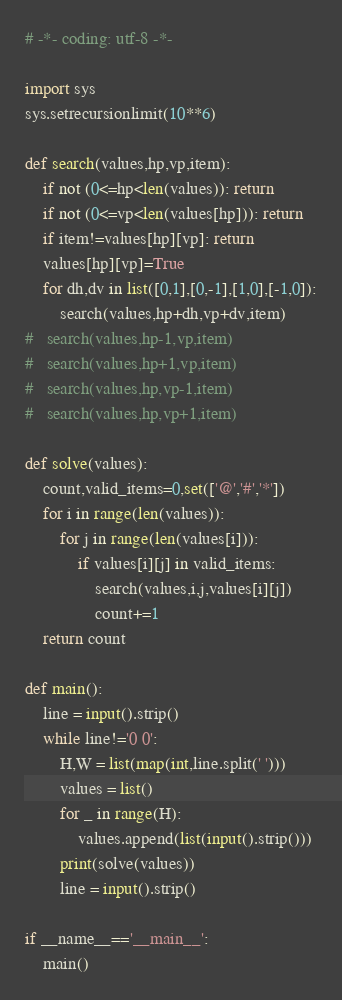Convert code to text. <code><loc_0><loc_0><loc_500><loc_500><_Python_># -*- coding: utf-8 -*-

import sys
sys.setrecursionlimit(10**6)

def search(values,hp,vp,item):
	if not (0<=hp<len(values)): return
	if not (0<=vp<len(values[hp])): return
	if item!=values[hp][vp]: return
	values[hp][vp]=True
	for dh,dv in list([0,1],[0,-1],[1,0],[-1,0]):
		search(values,hp+dh,vp+dv,item)
#	search(values,hp-1,vp,item)
#	search(values,hp+1,vp,item)
#	search(values,hp,vp-1,item)
#	search(values,hp,vp+1,item)

def solve(values):
	count,valid_items=0,set(['@','#','*'])
	for i in range(len(values)):
		for j in range(len(values[i])):
			if values[i][j] in valid_items:
				search(values,i,j,values[i][j])
				count+=1
	return count

def main():
	line = input().strip()
	while line!='0 0':
		H,W = list(map(int,line.split(' ')))
		values = list()
		for _ in range(H):
			values.append(list(input().strip()))
		print(solve(values))
		line = input().strip()

if __name__=='__main__':
	main()</code> 